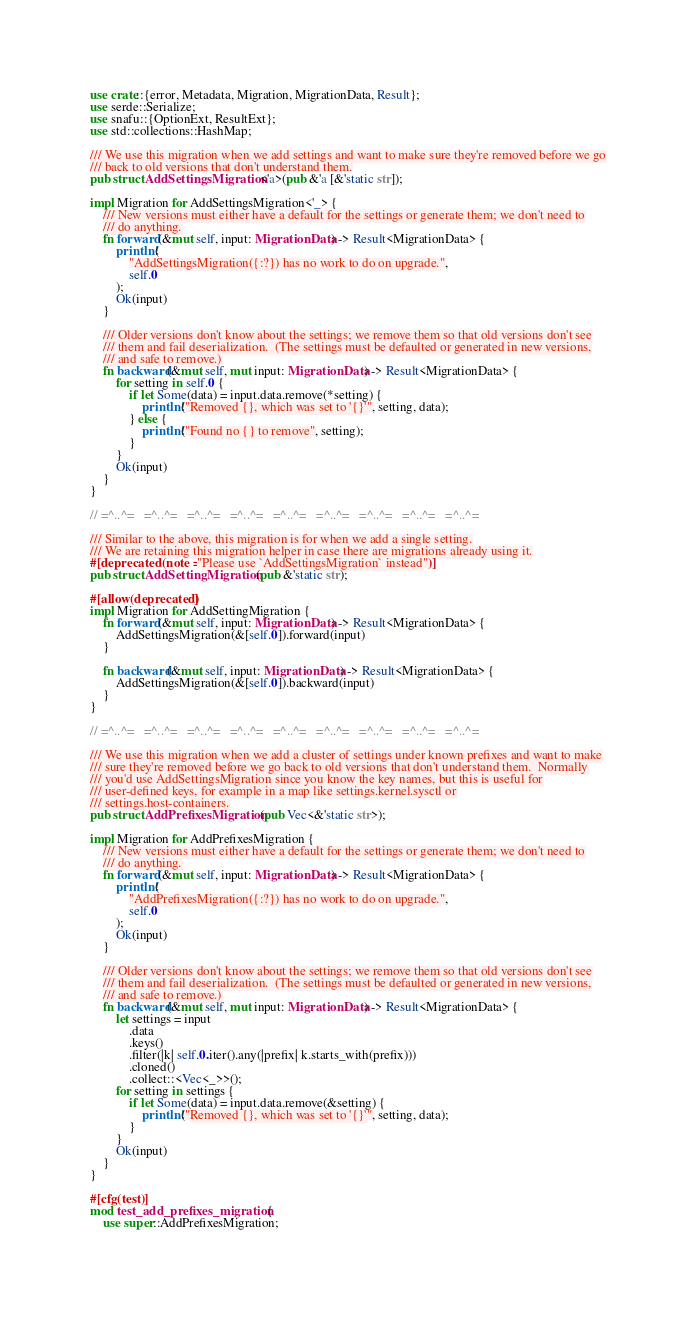<code> <loc_0><loc_0><loc_500><loc_500><_Rust_>use crate::{error, Metadata, Migration, MigrationData, Result};
use serde::Serialize;
use snafu::{OptionExt, ResultExt};
use std::collections::HashMap;

/// We use this migration when we add settings and want to make sure they're removed before we go
/// back to old versions that don't understand them.
pub struct AddSettingsMigration<'a>(pub &'a [&'static str]);

impl Migration for AddSettingsMigration<'_> {
    /// New versions must either have a default for the settings or generate them; we don't need to
    /// do anything.
    fn forward(&mut self, input: MigrationData) -> Result<MigrationData> {
        println!(
            "AddSettingsMigration({:?}) has no work to do on upgrade.",
            self.0
        );
        Ok(input)
    }

    /// Older versions don't know about the settings; we remove them so that old versions don't see
    /// them and fail deserialization.  (The settings must be defaulted or generated in new versions,
    /// and safe to remove.)
    fn backward(&mut self, mut input: MigrationData) -> Result<MigrationData> {
        for setting in self.0 {
            if let Some(data) = input.data.remove(*setting) {
                println!("Removed {}, which was set to '{}'", setting, data);
            } else {
                println!("Found no {} to remove", setting);
            }
        }
        Ok(input)
    }
}

// =^..^=   =^..^=   =^..^=   =^..^=   =^..^=   =^..^=   =^..^=   =^..^=   =^..^=

/// Similar to the above, this migration is for when we add a single setting.
/// We are retaining this migration helper in case there are migrations already using it.
#[deprecated(note = "Please use `AddSettingsMigration` instead")]
pub struct AddSettingMigration(pub &'static str);

#[allow(deprecated)]
impl Migration for AddSettingMigration {
    fn forward(&mut self, input: MigrationData) -> Result<MigrationData> {
        AddSettingsMigration(&[self.0]).forward(input)
    }

    fn backward(&mut self, input: MigrationData) -> Result<MigrationData> {
        AddSettingsMigration(&[self.0]).backward(input)
    }
}

// =^..^=   =^..^=   =^..^=   =^..^=   =^..^=   =^..^=   =^..^=   =^..^=   =^..^=

/// We use this migration when we add a cluster of settings under known prefixes and want to make
/// sure they're removed before we go back to old versions that don't understand them.  Normally
/// you'd use AddSettingsMigration since you know the key names, but this is useful for
/// user-defined keys, for example in a map like settings.kernel.sysctl or
/// settings.host-containers.
pub struct AddPrefixesMigration(pub Vec<&'static str>);

impl Migration for AddPrefixesMigration {
    /// New versions must either have a default for the settings or generate them; we don't need to
    /// do anything.
    fn forward(&mut self, input: MigrationData) -> Result<MigrationData> {
        println!(
            "AddPrefixesMigration({:?}) has no work to do on upgrade.",
            self.0
        );
        Ok(input)
    }

    /// Older versions don't know about the settings; we remove them so that old versions don't see
    /// them and fail deserialization.  (The settings must be defaulted or generated in new versions,
    /// and safe to remove.)
    fn backward(&mut self, mut input: MigrationData) -> Result<MigrationData> {
        let settings = input
            .data
            .keys()
            .filter(|k| self.0.iter().any(|prefix| k.starts_with(prefix)))
            .cloned()
            .collect::<Vec<_>>();
        for setting in settings {
            if let Some(data) = input.data.remove(&setting) {
                println!("Removed {}, which was set to '{}'", setting, data);
            }
        }
        Ok(input)
    }
}

#[cfg(test)]
mod test_add_prefixes_migration {
    use super::AddPrefixesMigration;</code> 